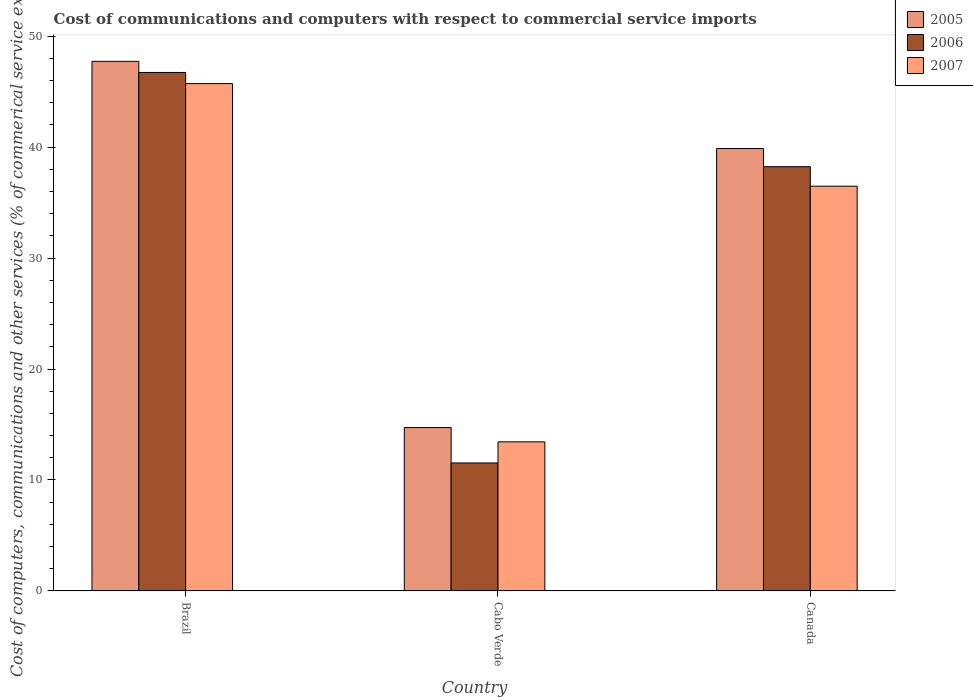Are the number of bars per tick equal to the number of legend labels?
Your response must be concise. Yes. Are the number of bars on each tick of the X-axis equal?
Your response must be concise. Yes. How many bars are there on the 1st tick from the right?
Your answer should be compact. 3. What is the cost of communications and computers in 2006 in Canada?
Provide a short and direct response. 38.24. Across all countries, what is the maximum cost of communications and computers in 2006?
Provide a short and direct response. 46.73. Across all countries, what is the minimum cost of communications and computers in 2006?
Your response must be concise. 11.53. In which country was the cost of communications and computers in 2007 minimum?
Provide a short and direct response. Cabo Verde. What is the total cost of communications and computers in 2006 in the graph?
Provide a succinct answer. 96.5. What is the difference between the cost of communications and computers in 2005 in Cabo Verde and that in Canada?
Keep it short and to the point. -25.15. What is the difference between the cost of communications and computers in 2006 in Brazil and the cost of communications and computers in 2007 in Canada?
Provide a short and direct response. 10.25. What is the average cost of communications and computers in 2007 per country?
Ensure brevity in your answer.  31.88. What is the difference between the cost of communications and computers of/in 2005 and cost of communications and computers of/in 2006 in Cabo Verde?
Offer a very short reply. 3.19. What is the ratio of the cost of communications and computers in 2006 in Brazil to that in Canada?
Provide a short and direct response. 1.22. Is the difference between the cost of communications and computers in 2005 in Brazil and Cabo Verde greater than the difference between the cost of communications and computers in 2006 in Brazil and Cabo Verde?
Ensure brevity in your answer.  No. What is the difference between the highest and the second highest cost of communications and computers in 2005?
Your response must be concise. 25.15. What is the difference between the highest and the lowest cost of communications and computers in 2005?
Provide a succinct answer. 33.01. What does the 2nd bar from the left in Brazil represents?
Offer a terse response. 2006. What does the 2nd bar from the right in Cabo Verde represents?
Offer a terse response. 2006. How many bars are there?
Keep it short and to the point. 9. Does the graph contain any zero values?
Give a very brief answer. No. Does the graph contain grids?
Keep it short and to the point. No. How many legend labels are there?
Keep it short and to the point. 3. How are the legend labels stacked?
Give a very brief answer. Vertical. What is the title of the graph?
Keep it short and to the point. Cost of communications and computers with respect to commercial service imports. Does "2001" appear as one of the legend labels in the graph?
Give a very brief answer. No. What is the label or title of the Y-axis?
Your answer should be very brief. Cost of computers, communications and other services (% of commerical service exports). What is the Cost of computers, communications and other services (% of commerical service exports) of 2005 in Brazil?
Provide a short and direct response. 47.73. What is the Cost of computers, communications and other services (% of commerical service exports) of 2006 in Brazil?
Ensure brevity in your answer.  46.73. What is the Cost of computers, communications and other services (% of commerical service exports) of 2007 in Brazil?
Your answer should be very brief. 45.72. What is the Cost of computers, communications and other services (% of commerical service exports) of 2005 in Cabo Verde?
Keep it short and to the point. 14.72. What is the Cost of computers, communications and other services (% of commerical service exports) of 2006 in Cabo Verde?
Provide a succinct answer. 11.53. What is the Cost of computers, communications and other services (% of commerical service exports) of 2007 in Cabo Verde?
Keep it short and to the point. 13.44. What is the Cost of computers, communications and other services (% of commerical service exports) of 2005 in Canada?
Offer a very short reply. 39.87. What is the Cost of computers, communications and other services (% of commerical service exports) in 2006 in Canada?
Your response must be concise. 38.24. What is the Cost of computers, communications and other services (% of commerical service exports) of 2007 in Canada?
Your response must be concise. 36.48. Across all countries, what is the maximum Cost of computers, communications and other services (% of commerical service exports) in 2005?
Provide a short and direct response. 47.73. Across all countries, what is the maximum Cost of computers, communications and other services (% of commerical service exports) of 2006?
Your answer should be compact. 46.73. Across all countries, what is the maximum Cost of computers, communications and other services (% of commerical service exports) in 2007?
Offer a terse response. 45.72. Across all countries, what is the minimum Cost of computers, communications and other services (% of commerical service exports) in 2005?
Make the answer very short. 14.72. Across all countries, what is the minimum Cost of computers, communications and other services (% of commerical service exports) of 2006?
Give a very brief answer. 11.53. Across all countries, what is the minimum Cost of computers, communications and other services (% of commerical service exports) in 2007?
Make the answer very short. 13.44. What is the total Cost of computers, communications and other services (% of commerical service exports) in 2005 in the graph?
Ensure brevity in your answer.  102.32. What is the total Cost of computers, communications and other services (% of commerical service exports) in 2006 in the graph?
Offer a very short reply. 96.5. What is the total Cost of computers, communications and other services (% of commerical service exports) in 2007 in the graph?
Keep it short and to the point. 95.64. What is the difference between the Cost of computers, communications and other services (% of commerical service exports) of 2005 in Brazil and that in Cabo Verde?
Your answer should be very brief. 33.01. What is the difference between the Cost of computers, communications and other services (% of commerical service exports) in 2006 in Brazil and that in Cabo Verde?
Make the answer very short. 35.19. What is the difference between the Cost of computers, communications and other services (% of commerical service exports) of 2007 in Brazil and that in Cabo Verde?
Your response must be concise. 32.29. What is the difference between the Cost of computers, communications and other services (% of commerical service exports) of 2005 in Brazil and that in Canada?
Provide a succinct answer. 7.86. What is the difference between the Cost of computers, communications and other services (% of commerical service exports) of 2006 in Brazil and that in Canada?
Offer a terse response. 8.49. What is the difference between the Cost of computers, communications and other services (% of commerical service exports) of 2007 in Brazil and that in Canada?
Your answer should be very brief. 9.25. What is the difference between the Cost of computers, communications and other services (% of commerical service exports) in 2005 in Cabo Verde and that in Canada?
Offer a terse response. -25.15. What is the difference between the Cost of computers, communications and other services (% of commerical service exports) of 2006 in Cabo Verde and that in Canada?
Offer a terse response. -26.7. What is the difference between the Cost of computers, communications and other services (% of commerical service exports) of 2007 in Cabo Verde and that in Canada?
Provide a short and direct response. -23.04. What is the difference between the Cost of computers, communications and other services (% of commerical service exports) in 2005 in Brazil and the Cost of computers, communications and other services (% of commerical service exports) in 2006 in Cabo Verde?
Give a very brief answer. 36.2. What is the difference between the Cost of computers, communications and other services (% of commerical service exports) of 2005 in Brazil and the Cost of computers, communications and other services (% of commerical service exports) of 2007 in Cabo Verde?
Make the answer very short. 34.29. What is the difference between the Cost of computers, communications and other services (% of commerical service exports) in 2006 in Brazil and the Cost of computers, communications and other services (% of commerical service exports) in 2007 in Cabo Verde?
Your answer should be very brief. 33.29. What is the difference between the Cost of computers, communications and other services (% of commerical service exports) of 2005 in Brazil and the Cost of computers, communications and other services (% of commerical service exports) of 2006 in Canada?
Offer a very short reply. 9.49. What is the difference between the Cost of computers, communications and other services (% of commerical service exports) of 2005 in Brazil and the Cost of computers, communications and other services (% of commerical service exports) of 2007 in Canada?
Offer a very short reply. 11.25. What is the difference between the Cost of computers, communications and other services (% of commerical service exports) of 2006 in Brazil and the Cost of computers, communications and other services (% of commerical service exports) of 2007 in Canada?
Offer a terse response. 10.25. What is the difference between the Cost of computers, communications and other services (% of commerical service exports) in 2005 in Cabo Verde and the Cost of computers, communications and other services (% of commerical service exports) in 2006 in Canada?
Offer a terse response. -23.51. What is the difference between the Cost of computers, communications and other services (% of commerical service exports) of 2005 in Cabo Verde and the Cost of computers, communications and other services (% of commerical service exports) of 2007 in Canada?
Give a very brief answer. -21.75. What is the difference between the Cost of computers, communications and other services (% of commerical service exports) in 2006 in Cabo Verde and the Cost of computers, communications and other services (% of commerical service exports) in 2007 in Canada?
Your answer should be very brief. -24.94. What is the average Cost of computers, communications and other services (% of commerical service exports) in 2005 per country?
Provide a short and direct response. 34.11. What is the average Cost of computers, communications and other services (% of commerical service exports) of 2006 per country?
Offer a very short reply. 32.17. What is the average Cost of computers, communications and other services (% of commerical service exports) in 2007 per country?
Offer a terse response. 31.88. What is the difference between the Cost of computers, communications and other services (% of commerical service exports) of 2005 and Cost of computers, communications and other services (% of commerical service exports) of 2007 in Brazil?
Provide a short and direct response. 2. What is the difference between the Cost of computers, communications and other services (% of commerical service exports) of 2005 and Cost of computers, communications and other services (% of commerical service exports) of 2006 in Cabo Verde?
Provide a succinct answer. 3.19. What is the difference between the Cost of computers, communications and other services (% of commerical service exports) of 2005 and Cost of computers, communications and other services (% of commerical service exports) of 2007 in Cabo Verde?
Your answer should be compact. 1.29. What is the difference between the Cost of computers, communications and other services (% of commerical service exports) of 2006 and Cost of computers, communications and other services (% of commerical service exports) of 2007 in Cabo Verde?
Offer a terse response. -1.9. What is the difference between the Cost of computers, communications and other services (% of commerical service exports) in 2005 and Cost of computers, communications and other services (% of commerical service exports) in 2006 in Canada?
Your response must be concise. 1.63. What is the difference between the Cost of computers, communications and other services (% of commerical service exports) of 2005 and Cost of computers, communications and other services (% of commerical service exports) of 2007 in Canada?
Your answer should be very brief. 3.39. What is the difference between the Cost of computers, communications and other services (% of commerical service exports) in 2006 and Cost of computers, communications and other services (% of commerical service exports) in 2007 in Canada?
Provide a succinct answer. 1.76. What is the ratio of the Cost of computers, communications and other services (% of commerical service exports) in 2005 in Brazil to that in Cabo Verde?
Keep it short and to the point. 3.24. What is the ratio of the Cost of computers, communications and other services (% of commerical service exports) in 2006 in Brazil to that in Cabo Verde?
Make the answer very short. 4.05. What is the ratio of the Cost of computers, communications and other services (% of commerical service exports) of 2007 in Brazil to that in Cabo Verde?
Your answer should be very brief. 3.4. What is the ratio of the Cost of computers, communications and other services (% of commerical service exports) of 2005 in Brazil to that in Canada?
Provide a succinct answer. 1.2. What is the ratio of the Cost of computers, communications and other services (% of commerical service exports) in 2006 in Brazil to that in Canada?
Offer a terse response. 1.22. What is the ratio of the Cost of computers, communications and other services (% of commerical service exports) of 2007 in Brazil to that in Canada?
Make the answer very short. 1.25. What is the ratio of the Cost of computers, communications and other services (% of commerical service exports) in 2005 in Cabo Verde to that in Canada?
Provide a short and direct response. 0.37. What is the ratio of the Cost of computers, communications and other services (% of commerical service exports) in 2006 in Cabo Verde to that in Canada?
Your answer should be compact. 0.3. What is the ratio of the Cost of computers, communications and other services (% of commerical service exports) of 2007 in Cabo Verde to that in Canada?
Provide a succinct answer. 0.37. What is the difference between the highest and the second highest Cost of computers, communications and other services (% of commerical service exports) in 2005?
Provide a succinct answer. 7.86. What is the difference between the highest and the second highest Cost of computers, communications and other services (% of commerical service exports) in 2006?
Your answer should be very brief. 8.49. What is the difference between the highest and the second highest Cost of computers, communications and other services (% of commerical service exports) in 2007?
Provide a short and direct response. 9.25. What is the difference between the highest and the lowest Cost of computers, communications and other services (% of commerical service exports) in 2005?
Your answer should be compact. 33.01. What is the difference between the highest and the lowest Cost of computers, communications and other services (% of commerical service exports) of 2006?
Provide a succinct answer. 35.19. What is the difference between the highest and the lowest Cost of computers, communications and other services (% of commerical service exports) in 2007?
Give a very brief answer. 32.29. 